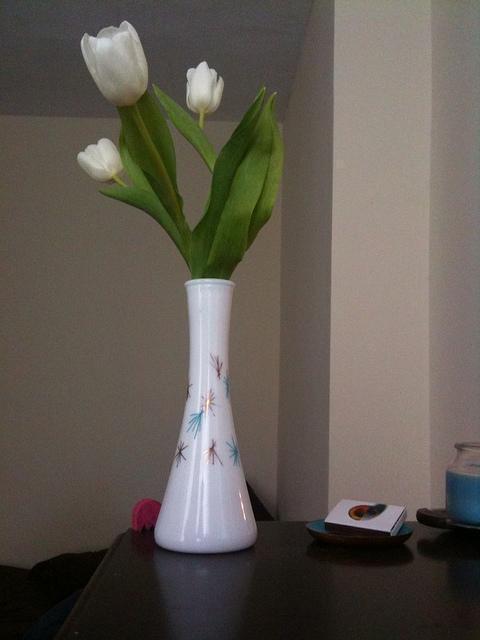How many vases are there?
Give a very brief answer. 1. How many forks are there?
Give a very brief answer. 0. How many people are under the umbrella?
Give a very brief answer. 0. 